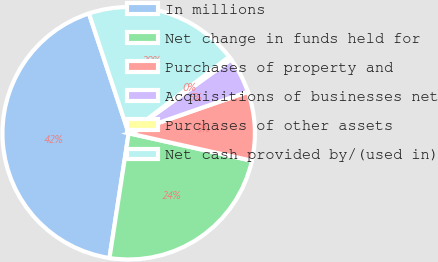<chart> <loc_0><loc_0><loc_500><loc_500><pie_chart><fcel>In millions<fcel>Net change in funds held for<fcel>Purchases of property and<fcel>Acquisitions of businesses net<fcel>Purchases of other assets<fcel>Net cash provided by/(used in)<nl><fcel>42.47%<fcel>23.94%<fcel>8.82%<fcel>4.62%<fcel>0.41%<fcel>19.74%<nl></chart> 